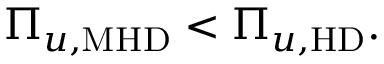Convert formula to latex. <formula><loc_0><loc_0><loc_500><loc_500>\begin{array} { r } { \Pi _ { u , M H D } < \Pi _ { u , H D } . } \end{array}</formula> 